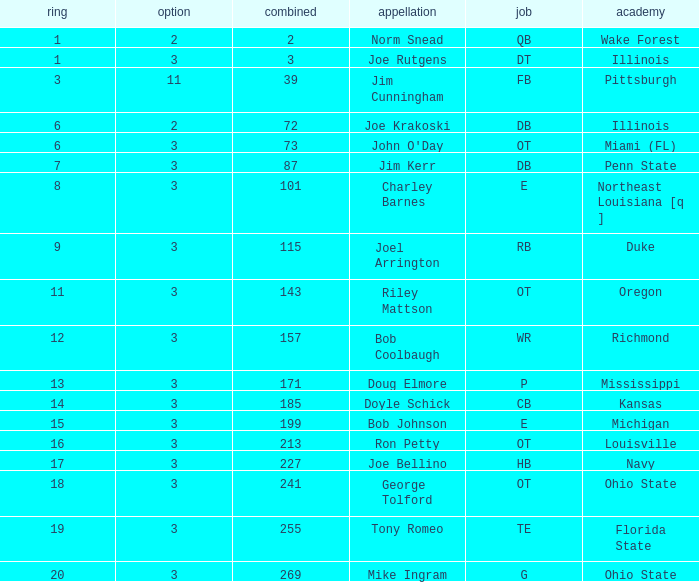How many overalls have charley barnes as the name, with a pick less than 3? None. 